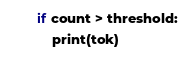Convert code to text. <code><loc_0><loc_0><loc_500><loc_500><_Python_>    if count > threshold:
        print(tok)



</code> 